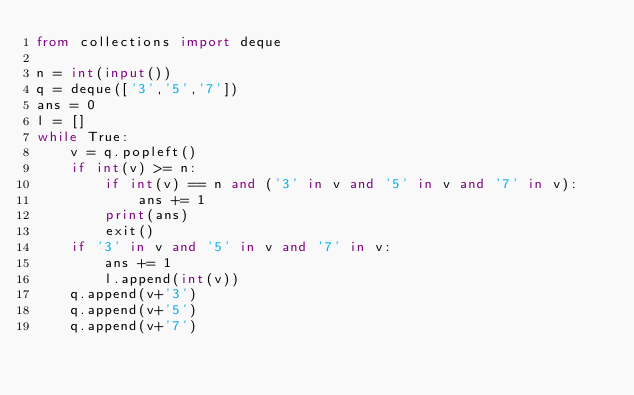Convert code to text. <code><loc_0><loc_0><loc_500><loc_500><_Python_>from collections import deque

n = int(input())
q = deque(['3','5','7'])
ans = 0
l = []
while True:
    v = q.popleft()
    if int(v) >= n:
        if int(v) == n and ('3' in v and '5' in v and '7' in v):
            ans += 1
        print(ans)
        exit() 
    if '3' in v and '5' in v and '7' in v:
        ans += 1
        l.append(int(v))
    q.append(v+'3')
    q.append(v+'5')
    q.append(v+'7')</code> 